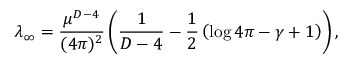<formula> <loc_0><loc_0><loc_500><loc_500>\lambda _ { \infty } = \frac { \mu ^ { D - 4 } } { ( 4 \pi ) ^ { 2 } } \left ( \frac { 1 } { D - 4 } - \frac { 1 } { 2 } \left ( \log 4 \pi - \gamma + 1 \right ) \right ) ,</formula> 